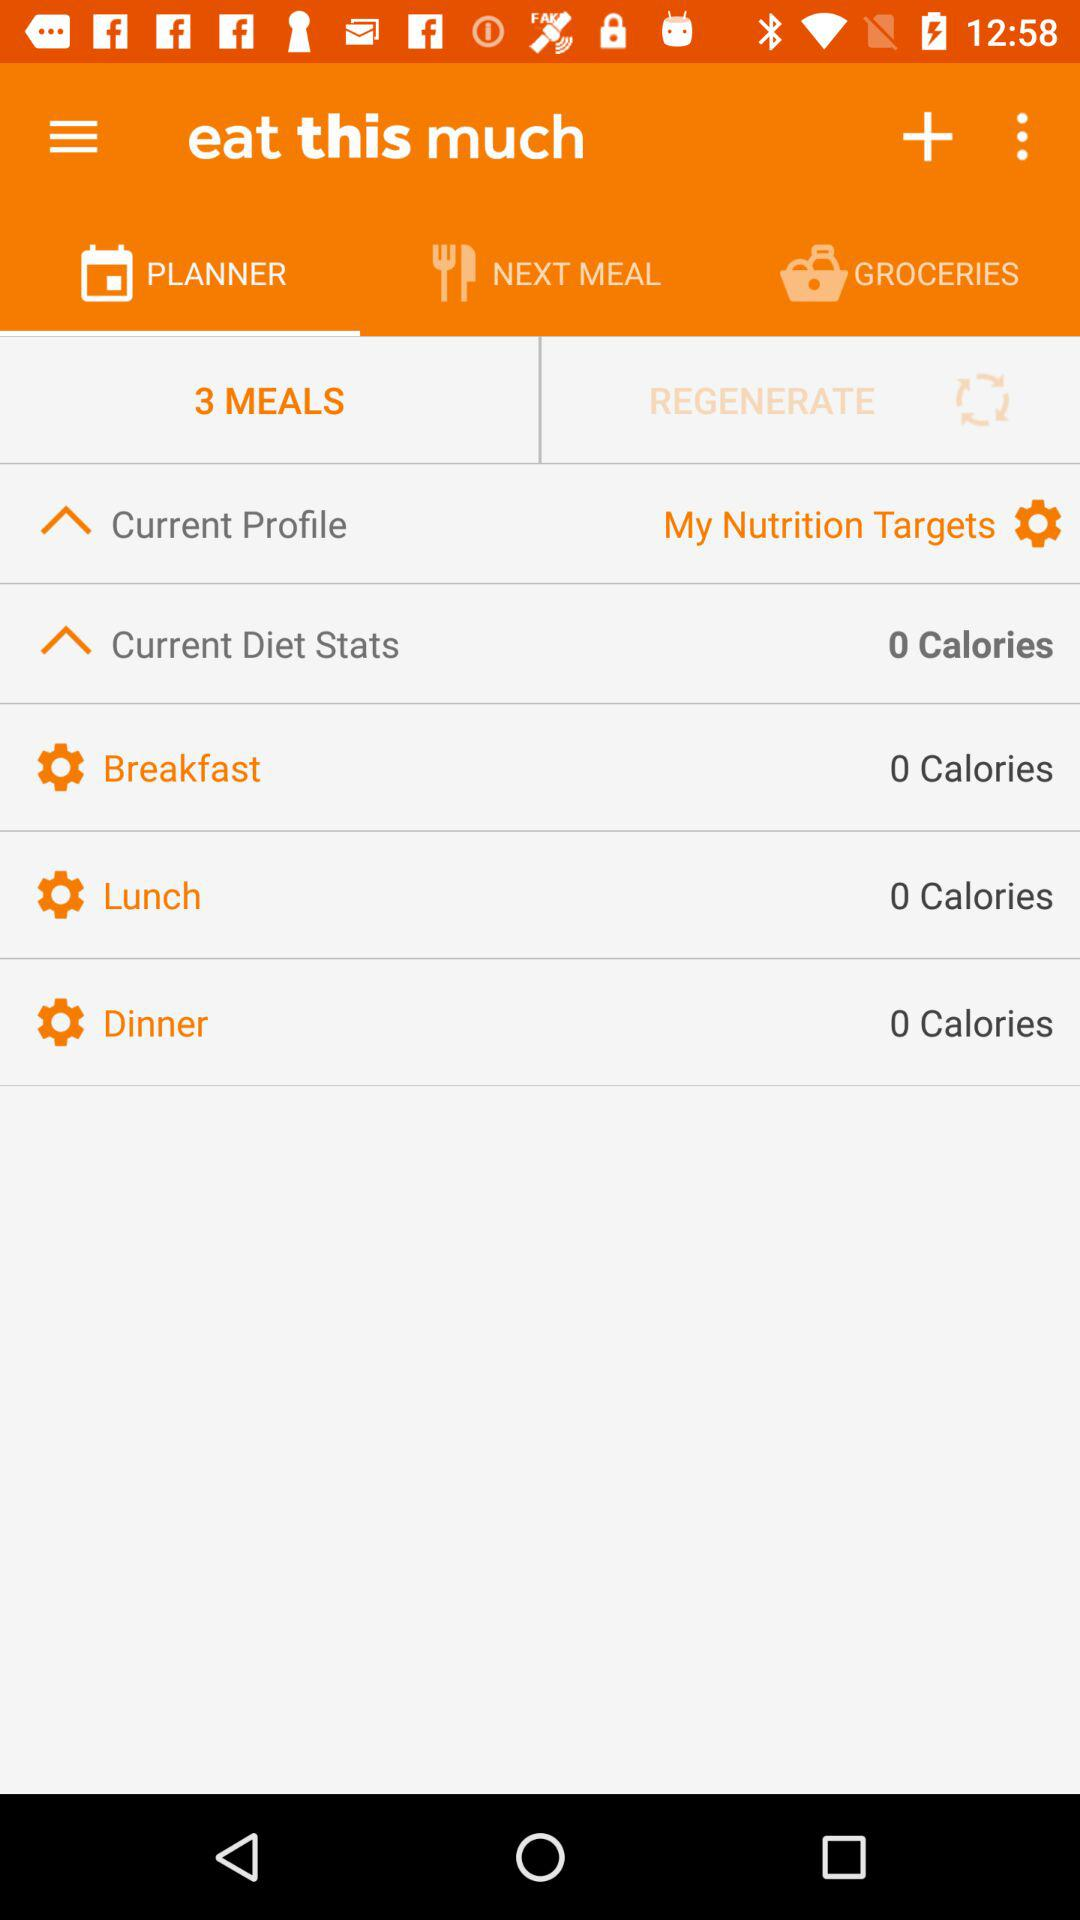How many meals have 0 calories?
Answer the question using a single word or phrase. 3 